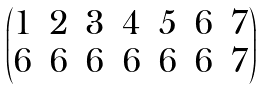Convert formula to latex. <formula><loc_0><loc_0><loc_500><loc_500>\begin{pmatrix} 1 & 2 & 3 & 4 & 5 & 6 & 7 \\ 6 & 6 & 6 & 6 & 6 & 6 & 7 \end{pmatrix}</formula> 